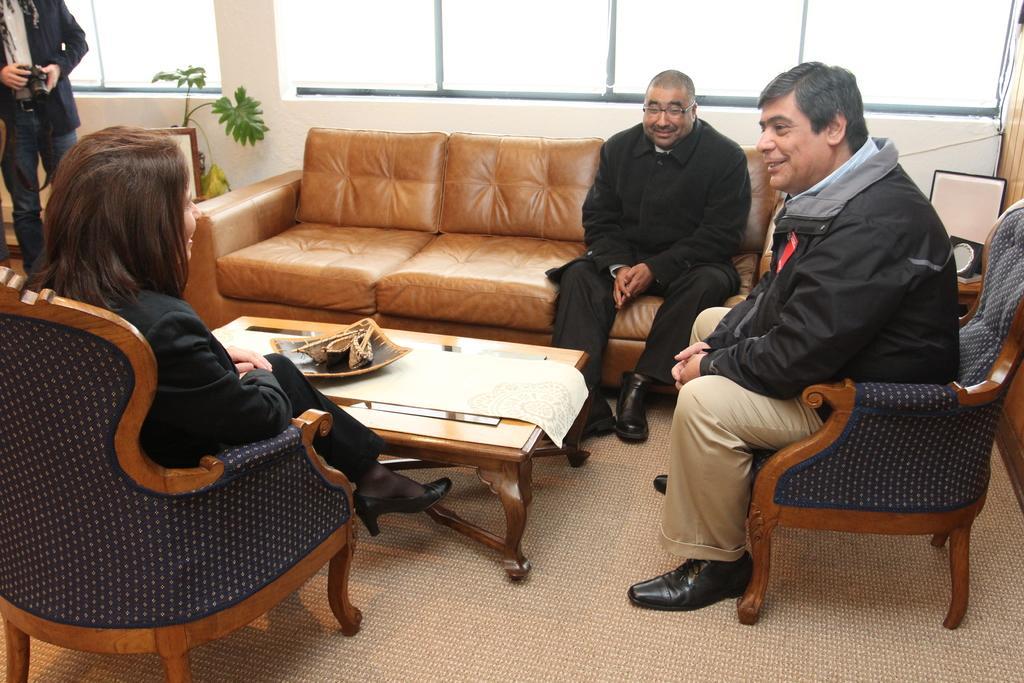Describe this image in one or two sentences. In this picture we can see four persons were here woman sitting on chair and man sitting on sofa and smiling and in front of them there is table and on table we can see bowl and in background we can see windows, tree 